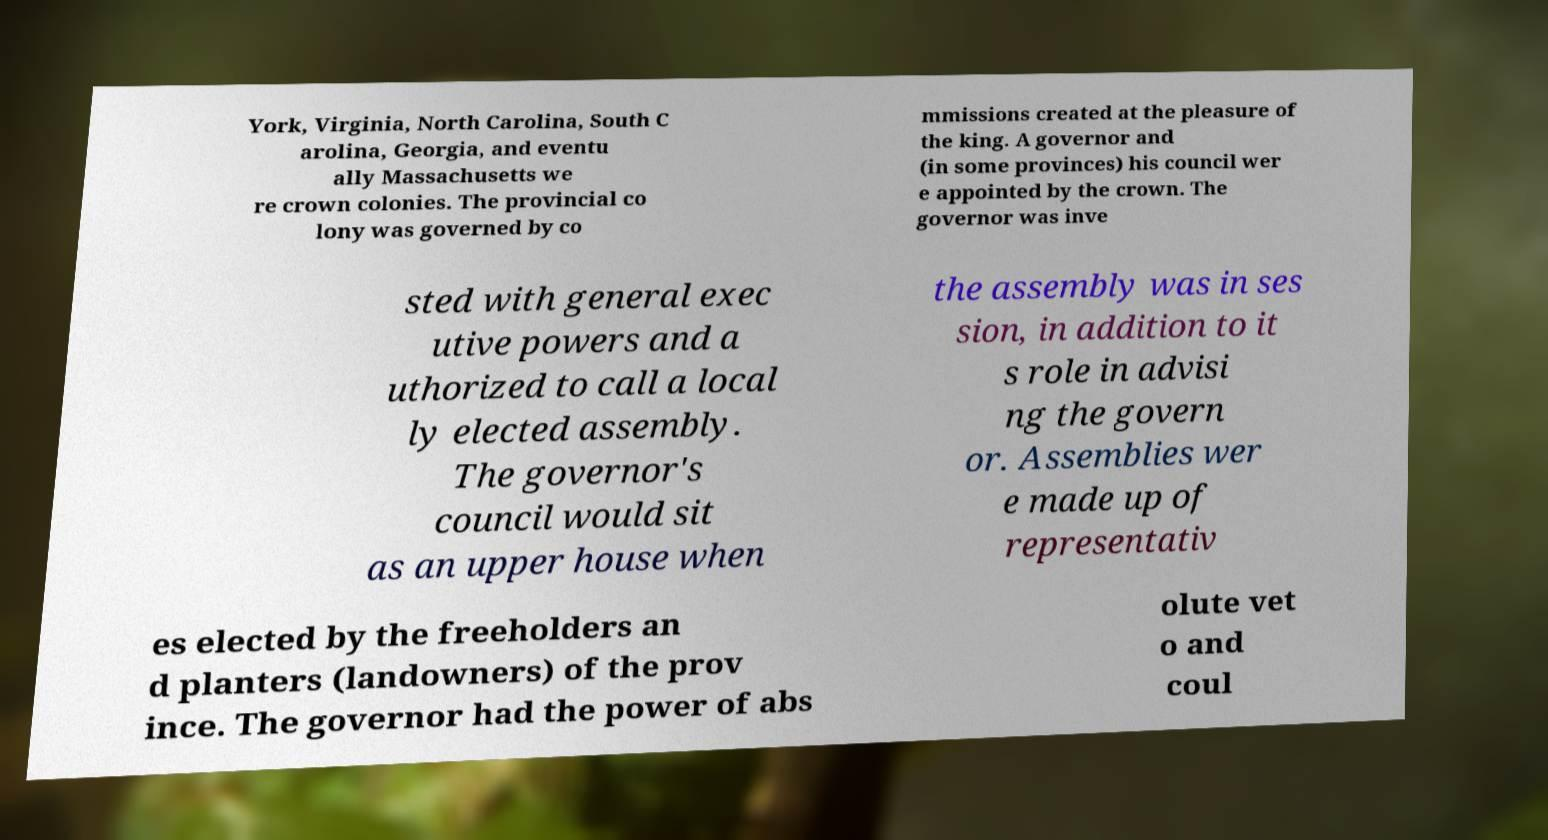There's text embedded in this image that I need extracted. Can you transcribe it verbatim? York, Virginia, North Carolina, South C arolina, Georgia, and eventu ally Massachusetts we re crown colonies. The provincial co lony was governed by co mmissions created at the pleasure of the king. A governor and (in some provinces) his council wer e appointed by the crown. The governor was inve sted with general exec utive powers and a uthorized to call a local ly elected assembly. The governor's council would sit as an upper house when the assembly was in ses sion, in addition to it s role in advisi ng the govern or. Assemblies wer e made up of representativ es elected by the freeholders an d planters (landowners) of the prov ince. The governor had the power of abs olute vet o and coul 